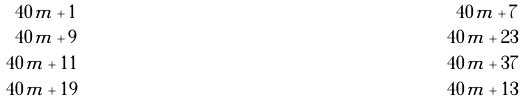<formula> <loc_0><loc_0><loc_500><loc_500>4 0 m + 1 & & 4 0 m + 7 \\ 4 0 m + 9 & & 4 0 m + 2 3 \\ 4 0 m + 1 1 & & 4 0 m + 3 7 \\ 4 0 m + 1 9 & & 4 0 m + 1 3</formula> 